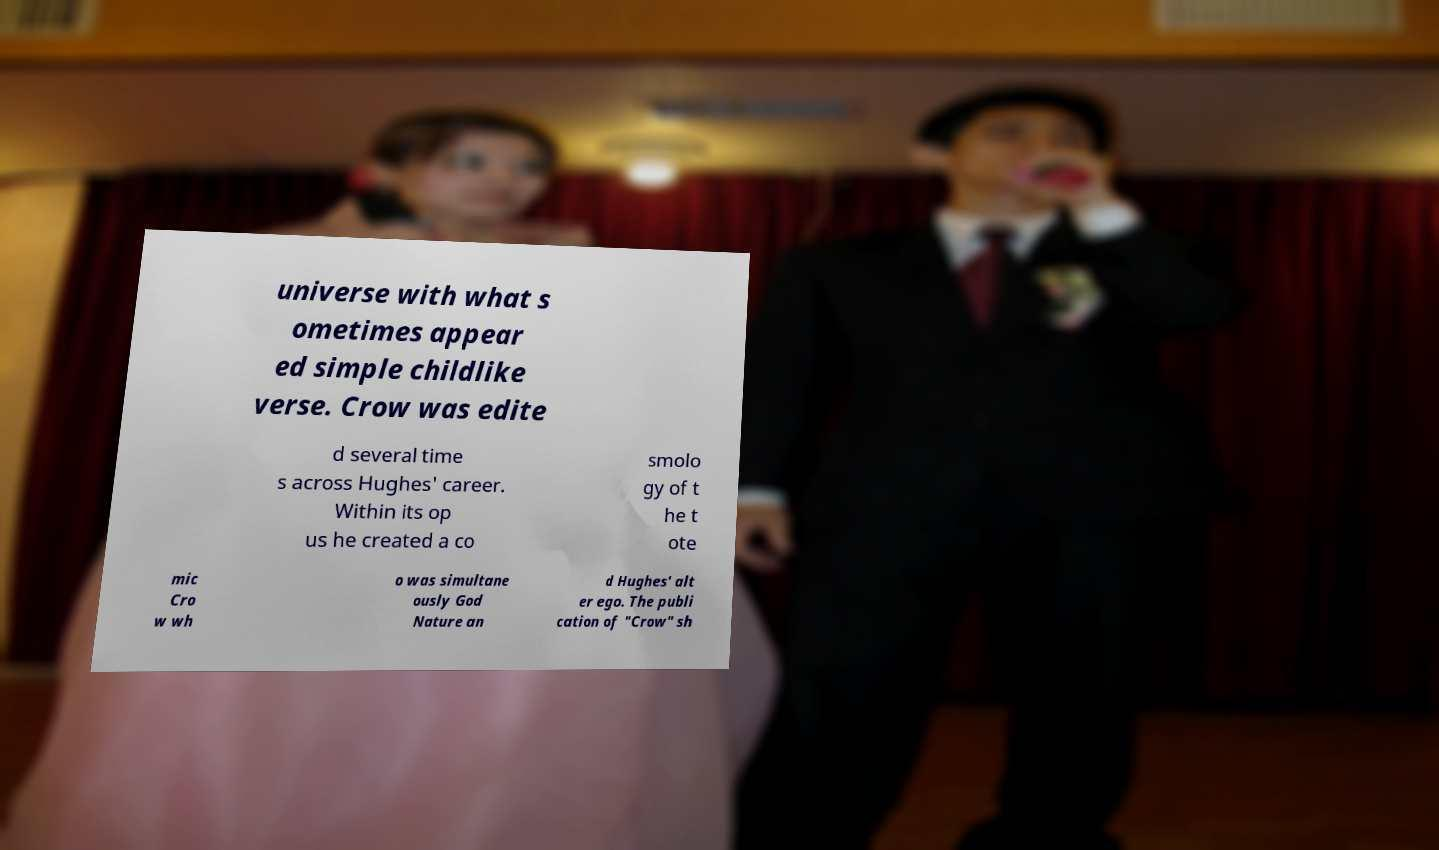What messages or text are displayed in this image? I need them in a readable, typed format. universe with what s ometimes appear ed simple childlike verse. Crow was edite d several time s across Hughes' career. Within its op us he created a co smolo gy of t he t ote mic Cro w wh o was simultane ously God Nature an d Hughes' alt er ego. The publi cation of "Crow" sh 